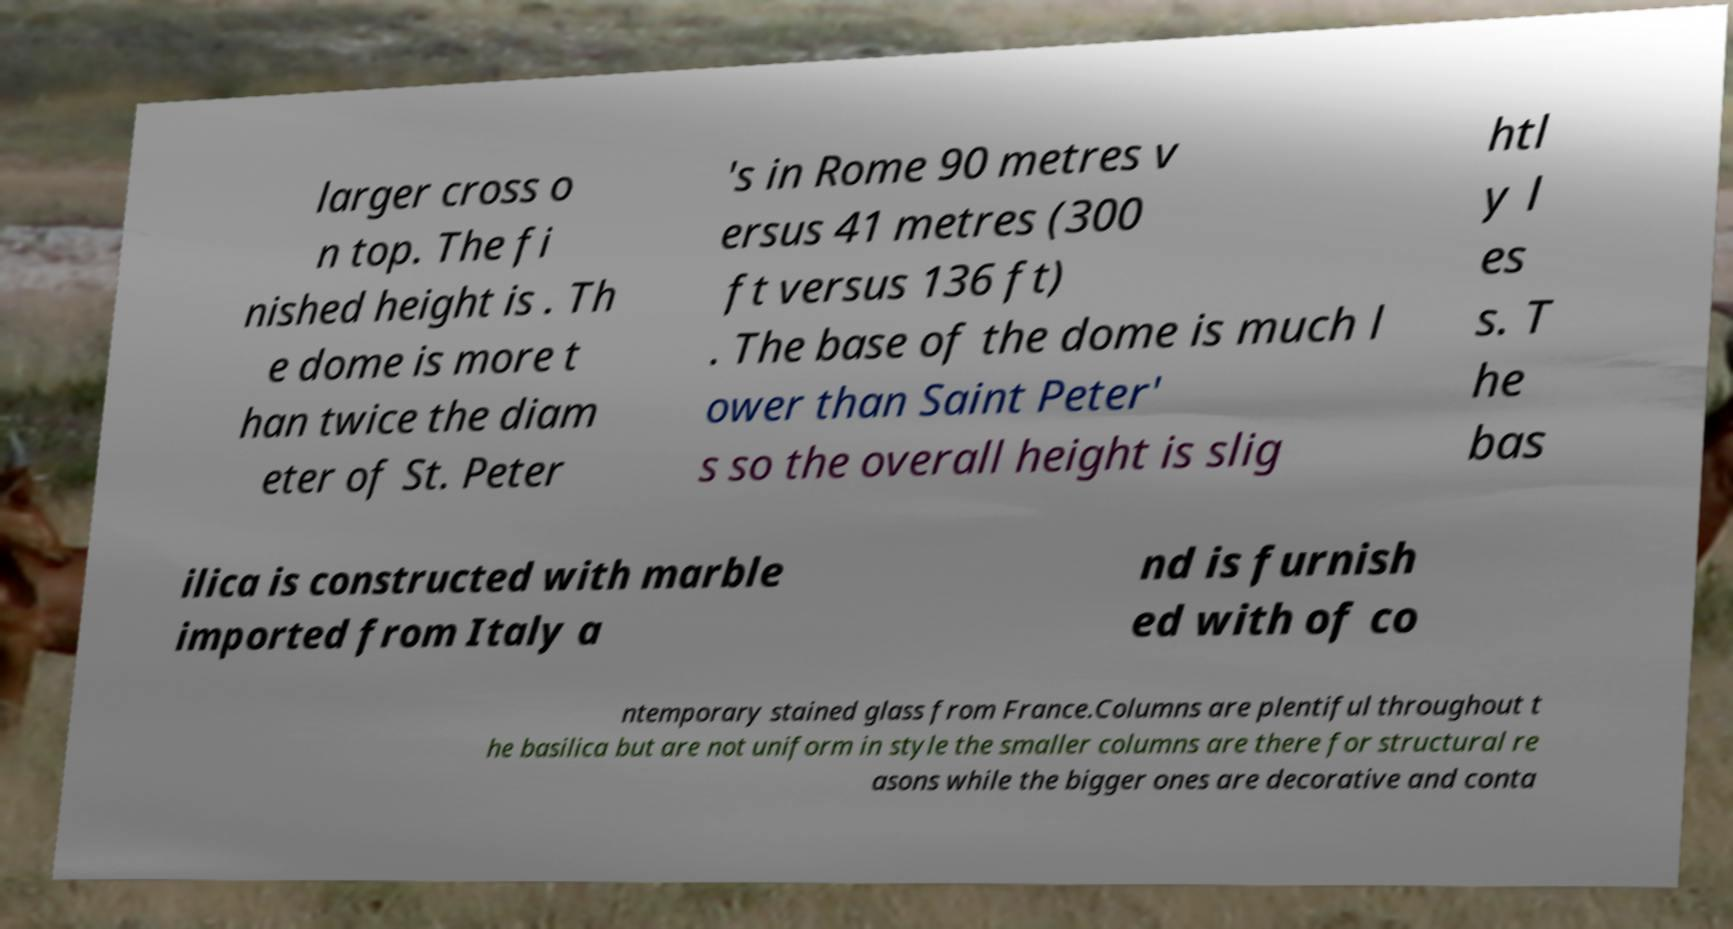Can you accurately transcribe the text from the provided image for me? larger cross o n top. The fi nished height is . Th e dome is more t han twice the diam eter of St. Peter 's in Rome 90 metres v ersus 41 metres (300 ft versus 136 ft) . The base of the dome is much l ower than Saint Peter' s so the overall height is slig htl y l es s. T he bas ilica is constructed with marble imported from Italy a nd is furnish ed with of co ntemporary stained glass from France.Columns are plentiful throughout t he basilica but are not uniform in style the smaller columns are there for structural re asons while the bigger ones are decorative and conta 